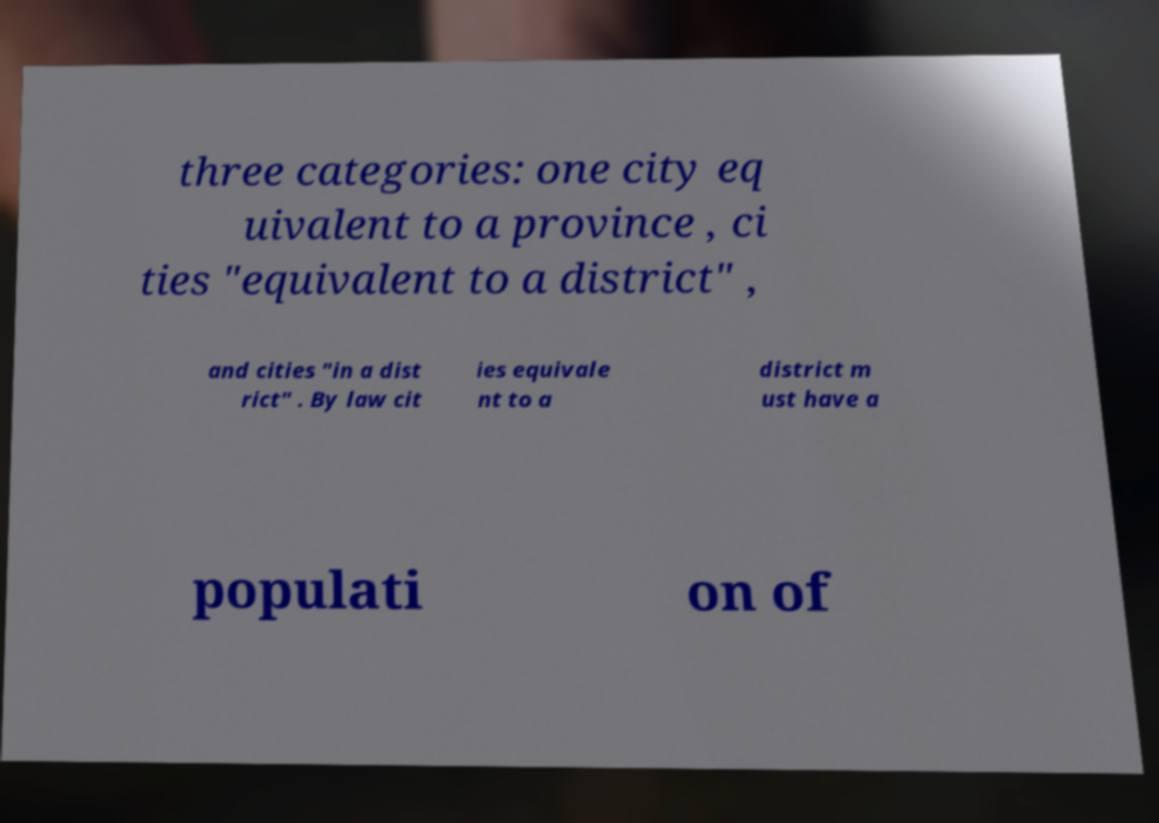Could you assist in decoding the text presented in this image and type it out clearly? three categories: one city eq uivalent to a province , ci ties "equivalent to a district" , and cities "in a dist rict" . By law cit ies equivale nt to a district m ust have a populati on of 